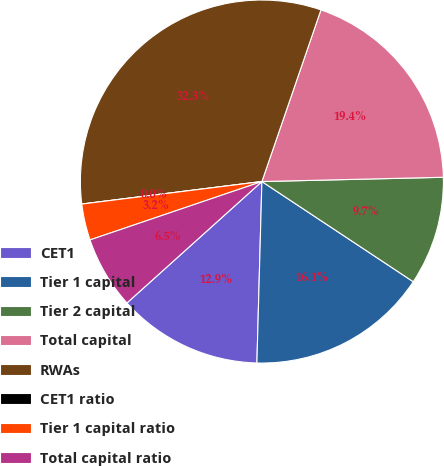Convert chart. <chart><loc_0><loc_0><loc_500><loc_500><pie_chart><fcel>CET1<fcel>Tier 1 capital<fcel>Tier 2 capital<fcel>Total capital<fcel>RWAs<fcel>CET1 ratio<fcel>Tier 1 capital ratio<fcel>Total capital ratio<nl><fcel>12.9%<fcel>16.13%<fcel>9.68%<fcel>19.35%<fcel>32.25%<fcel>0.0%<fcel>3.23%<fcel>6.45%<nl></chart> 